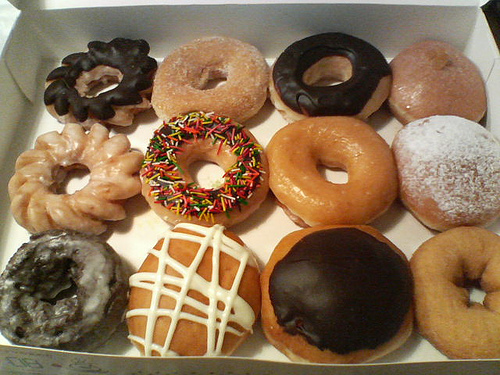How would you describe the texture of these doughnuts based on their appearance? Judging by the image, these doughnuts appear to have a variety of textures, from the smooth and shiny glaze on some to the fluffy, sugar-coated exterior on others. The one with sprinkles likely adds a slight crunch, whereas the powdered ones may have a softer, melt-in-your-mouth quality. 